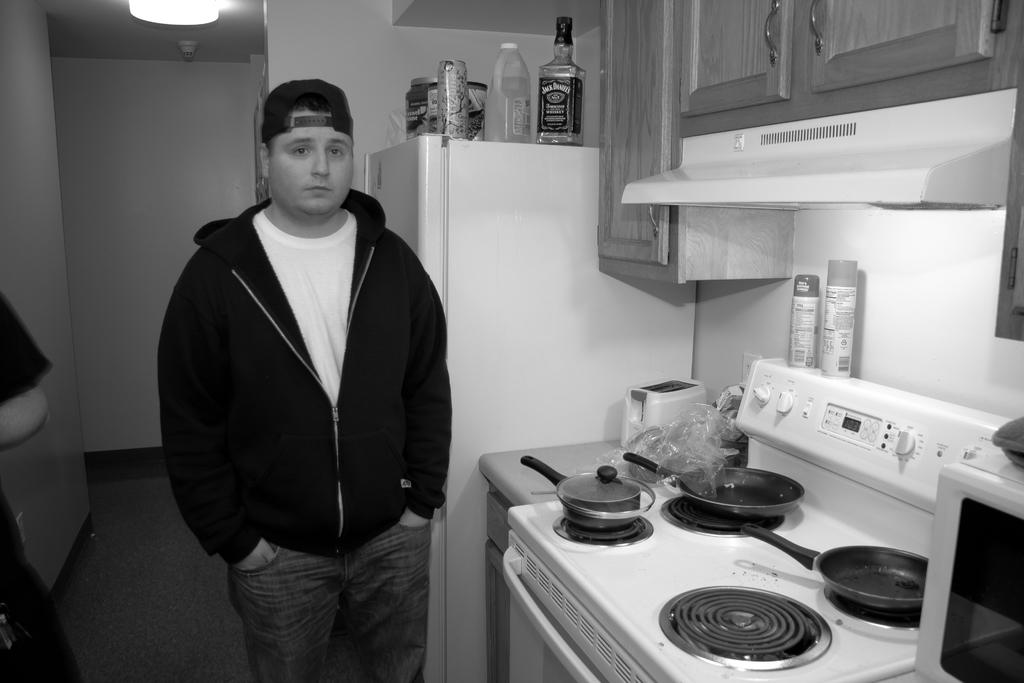How many people are present in the image? There are two people standing in the image. What surface are the people standing on? The people are standing on the floor. What kitchen appliances can be seen in the image? There is a refrigerator and a stove in the image. What cooking utensils are visible in the image? There are pans in the image. What type of containers are present in the image? There are bottles in the image. What type of storage units are in the image? There are cupboards in the image. What type of structure is present in the image? There are walls in the image. What type of illumination is present in the image? There is a light in the image. Can you describe any unspecified objects in the image? There are some unspecified objects in the image, but their details are not provided. Who is the servant attending to in the image? There is no servant present in the image. What verse is being recited by the people in the image? There is no verse being recited in the image. 